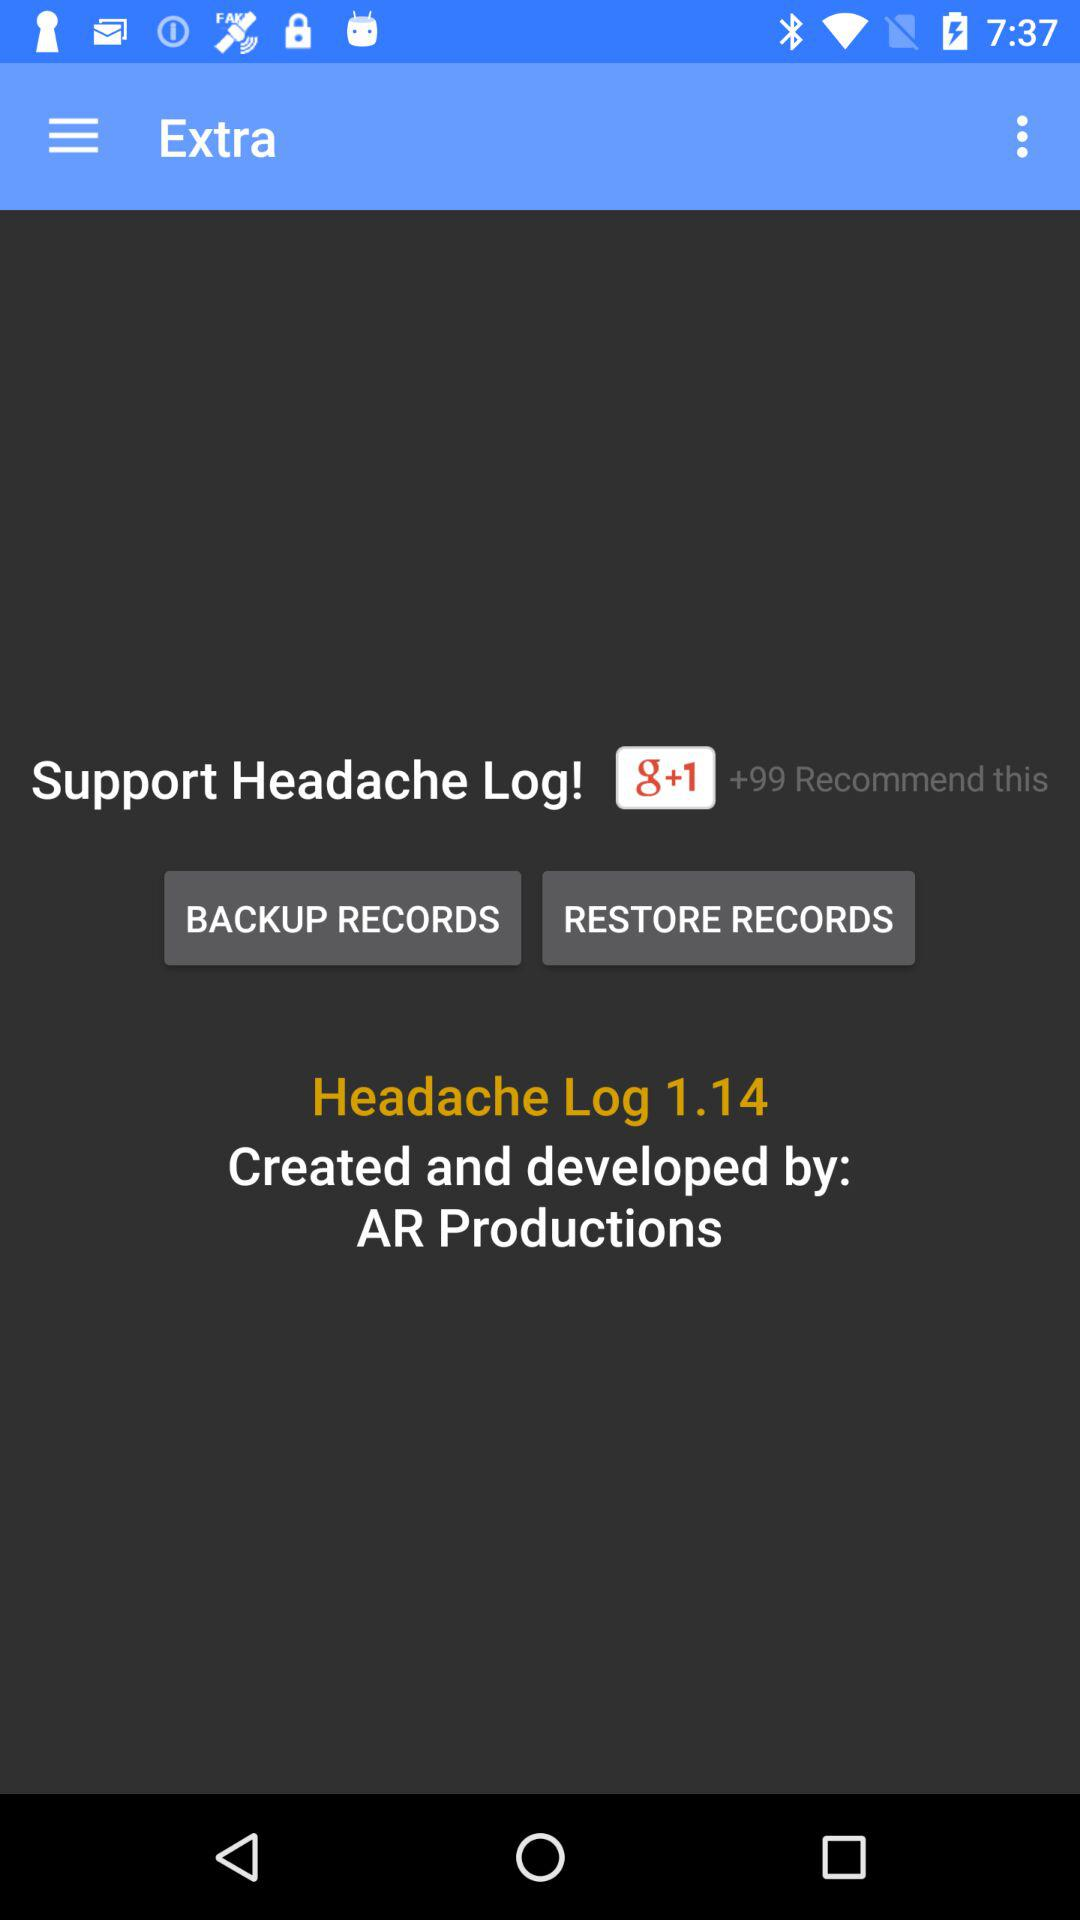Who developed the Headache Log 1.14? The Headache Log 1.14 was developed by AR Productions. 